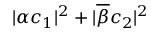Convert formula to latex. <formula><loc_0><loc_0><loc_500><loc_500>| \alpha c _ { 1 } | ^ { 2 } + | \overline { \beta } c _ { 2 } | ^ { 2 }</formula> 